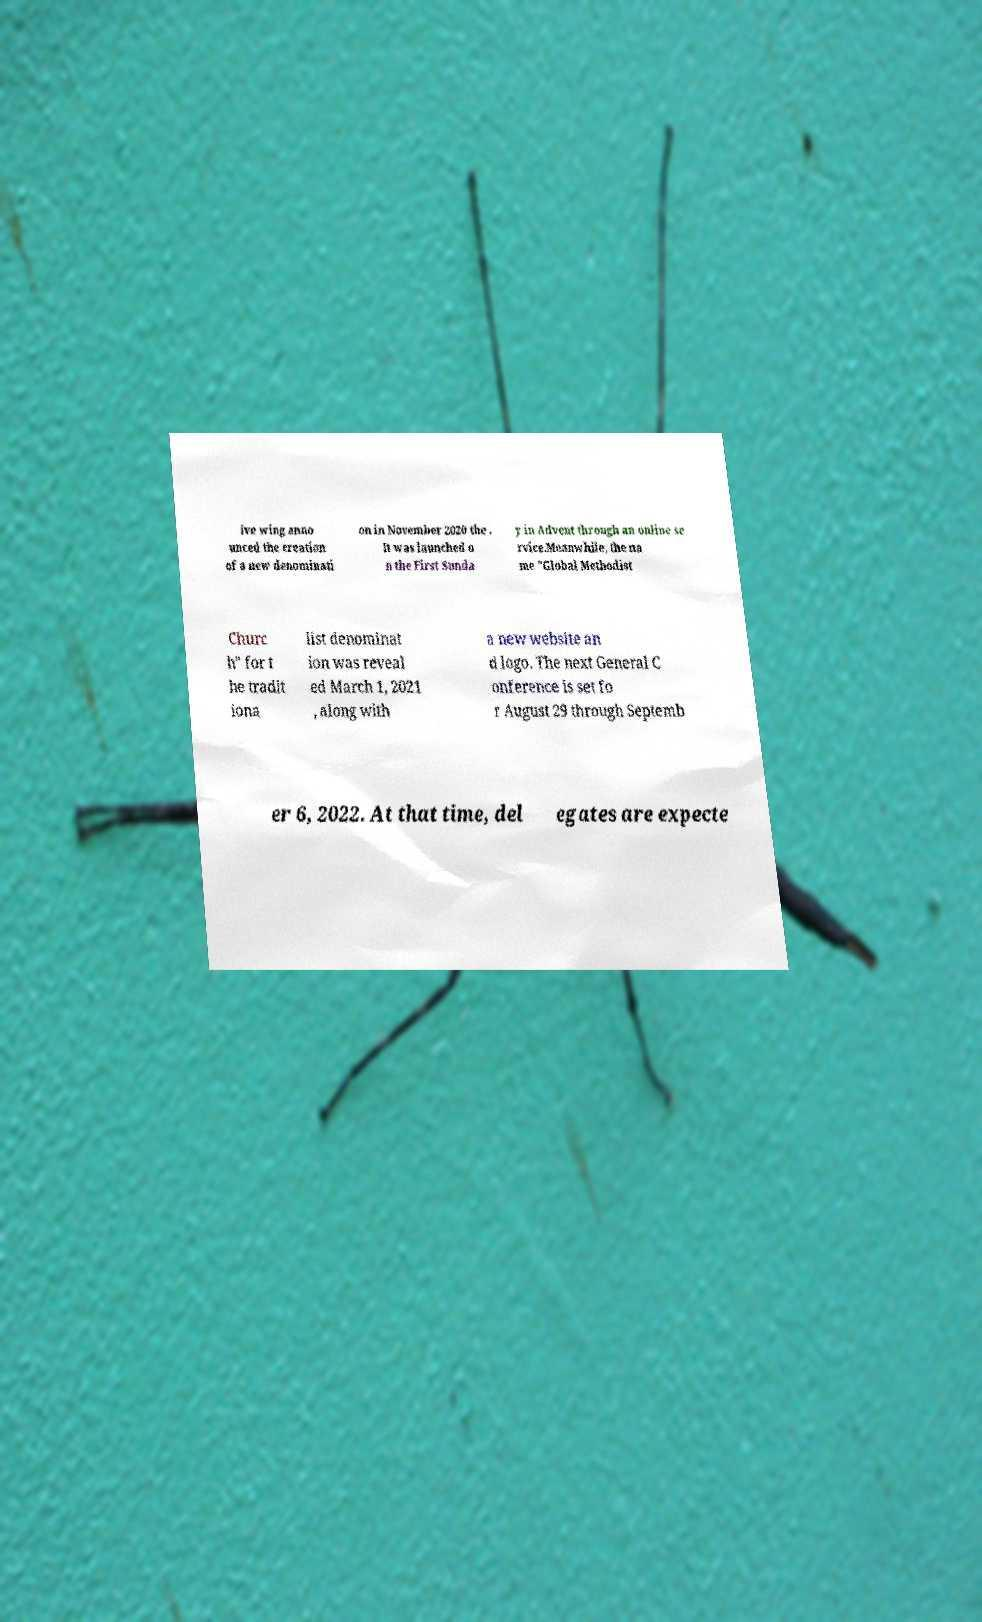What messages or text are displayed in this image? I need them in a readable, typed format. ive wing anno unced the creation of a new denominati on in November 2020 the . It was launched o n the First Sunda y in Advent through an online se rvice.Meanwhile, the na me "Global Methodist Churc h" for t he tradit iona list denominat ion was reveal ed March 1, 2021 , along with a new website an d logo. The next General C onference is set fo r August 29 through Septemb er 6, 2022. At that time, del egates are expecte 